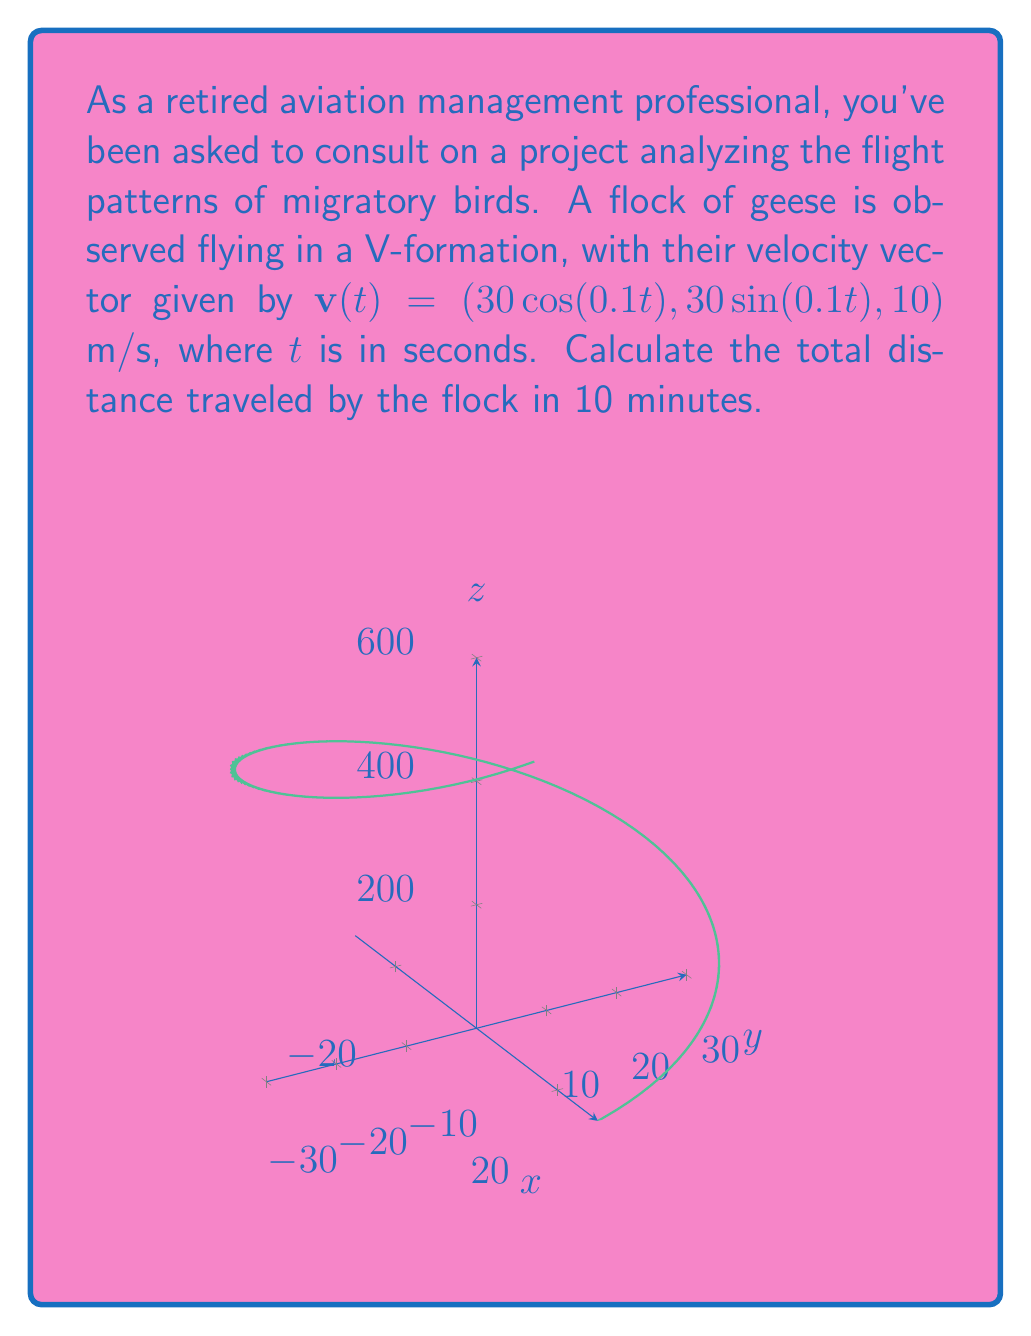Can you solve this math problem? Let's approach this step-by-step:

1) The velocity vector is given as $\mathbf{v}(t) = (30\cos(0.1t), 30\sin(0.1t), 10)$ m/s.

2) To find the total distance traveled, we need to calculate the arc length of the path. The formula for arc length in vector calculus is:

   $$s = \int_a^b |\mathbf{v}(t)| dt$$

3) First, let's calculate $|\mathbf{v}(t)|$:

   $$|\mathbf{v}(t)| = \sqrt{(30\cos(0.1t))^2 + (30\sin(0.1t))^2 + 10^2}$$

4) Simplify:
   
   $$|\mathbf{v}(t)| = \sqrt{900(\cos^2(0.1t) + \sin^2(0.1t)) + 100}$$
   
   $$|\mathbf{v}(t)| = \sqrt{900 + 100} = \sqrt{1000} = 10\sqrt{10}$$

5) Now, we can set up our integral:

   $$s = \int_0^{600} 10\sqrt{10} dt$$

   Note that we're integrating from 0 to 600 seconds (10 minutes).

6) Evaluate the integral:

   $$s = 10\sqrt{10} \cdot 600 = 6000\sqrt{10}$$

7) The result is in meters. To convert to kilometers:

   $$s = 6000\sqrt{10} / 1000 = 6\sqrt{10} \approx 18.97 \text{ km}$$
Answer: $6\sqrt{10}$ km or approximately 18.97 km 